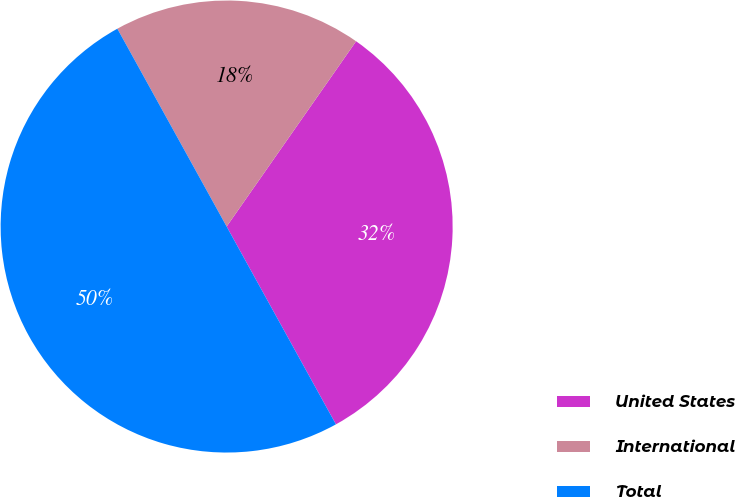Convert chart to OTSL. <chart><loc_0><loc_0><loc_500><loc_500><pie_chart><fcel>United States<fcel>International<fcel>Total<nl><fcel>32.26%<fcel>17.74%<fcel>50.0%<nl></chart> 